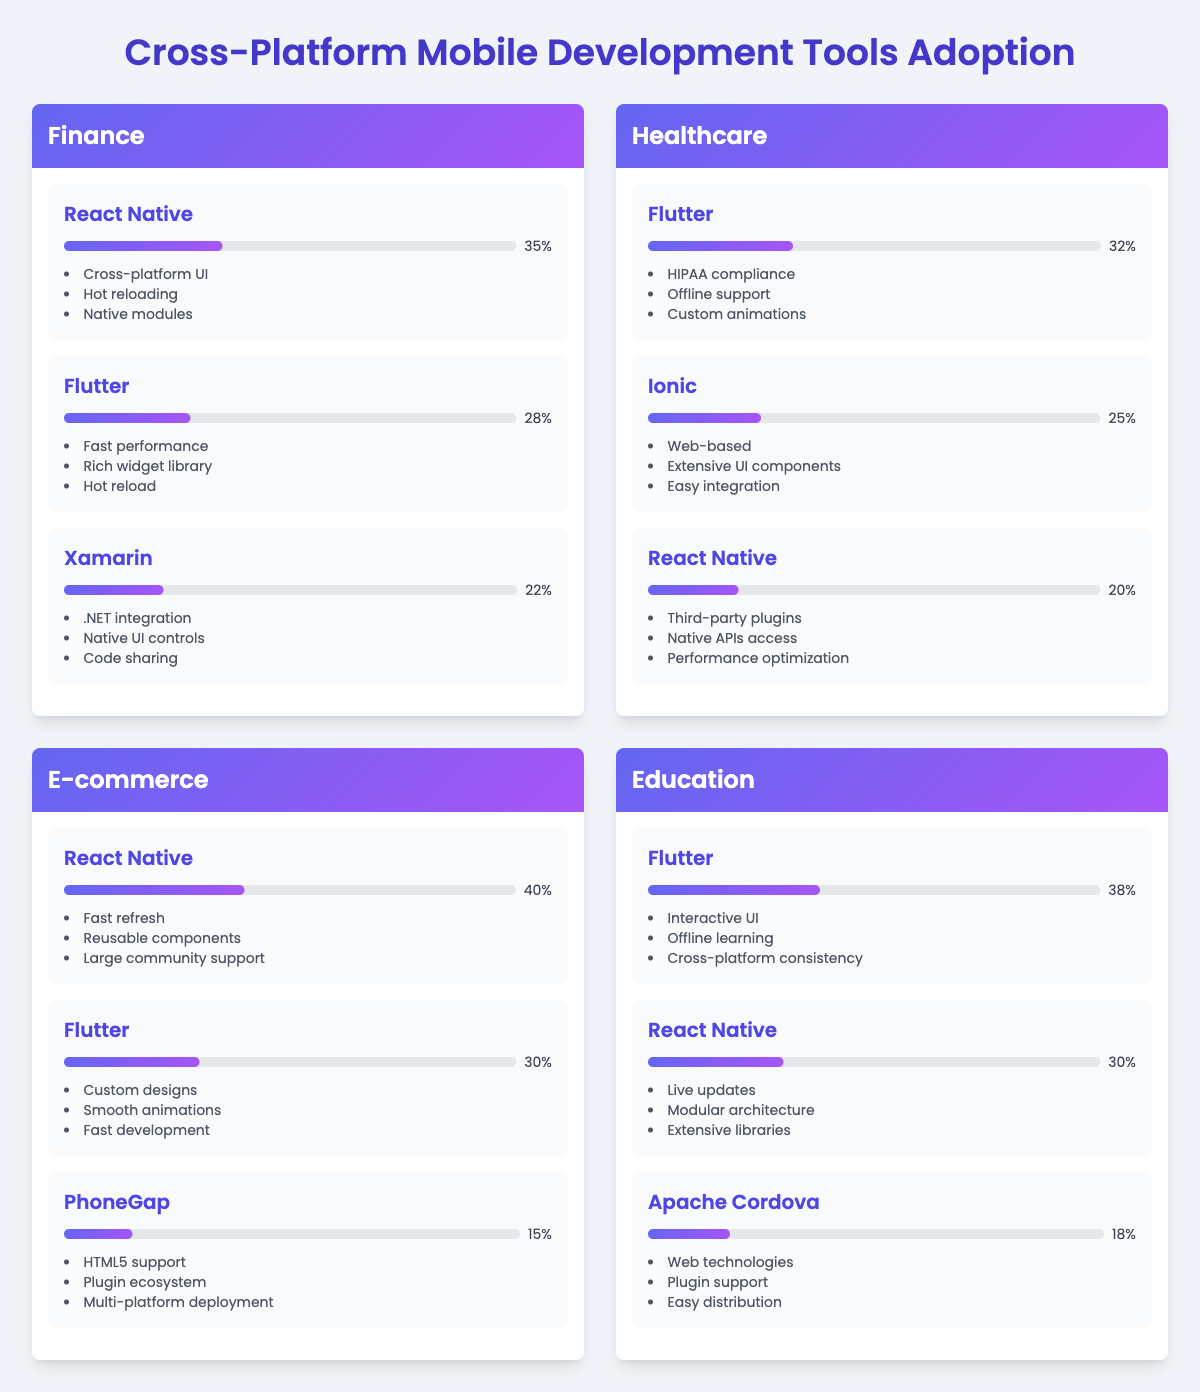What is the adoption rate of Flutter in the Finance industry? The adoption rate for Flutter in the Finance industry is listed in the tools section. Referring to that section shows that Flutter has an adoption rate of 28%.
Answer: 28% Which mobile development tool has the highest adoption rate in E-commerce? By examining the adoption rates in the E-commerce section, React Native has the highest adoption rate at 40%.
Answer: 40% What are the popular features of React Native in the Healthcare industry? Checking the tools listed under Healthcare, React Native has several listed features, specifically: Third-party plugins, Native APIs access, and Performance optimization.
Answer: Third-party plugins, Native APIs access, Performance optimization Is Flutter used more widely than Xamarin in Finance? Comparing the adoption rates, Flutter at 28% is indeed higher than Xamarin at 22%, so the statement is true.
Answer: Yes What is the average adoption rate of React Native across all industries presented? The adoption rates of React Native in different industries are: 35% (Finance), 20% (Healthcare), 40% (E-commerce), and 30% (Education). The average is calculated as (35 + 20 + 40 + 30) / 4 = 31.25%.
Answer: 31.25% Which tool is the least adopted in E-commerce? In the E-commerce section, PhoneGap is listed with an adoption rate of 15%, which is lower than both React Native and Flutter.
Answer: PhoneGap If you combine the adoption rates of Flutter in Finance and E-commerce, what is the total? The adoption rate of Flutter in Finance is 28% and in E-commerce it is 30%. Adding these two rates together gives: 28% + 30% = 58%.
Answer: 58% In the Education industry, how does the adoption rate of Apache Cordova compare to that of Flutter? In Education, Flutter has an adoption rate of 38% while Apache Cordova’s rate is 18%. Comparing these, Flutter is more widely adopted than Apache Cordova.
Answer: Flutter is more widely adopted Which industry shows the lowest adoption rate for React Native? React Native's lowest adoption rate is found in the Healthcare industry at 20%, compared to its other rates in Finance (35%), E-commerce (40%), and Education (30%).
Answer: Healthcare What is the total adoption rate for all tools in the Healthcare industry? Summing the adoption rates in Healthcare: Flutter (32%) + Ionic (25%) + React Native (20%) results in 32 + 25 + 20 = 77%.
Answer: 77% 